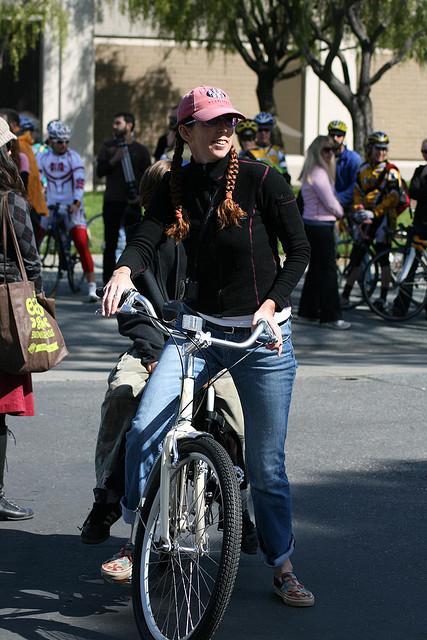Is the woman about to ride the bike?
Be succinct. Yes. What kind of vehicle is this?
Write a very short answer. Bicycle. Does her bike have a light on the front?
Answer briefly. No. What kind of shoes is the biker wearing?
Concise answer only. Tennis. What color is the hat?
Be succinct. Pink. What are the people on?
Give a very brief answer. Bikes. What is the girl doing?
Give a very brief answer. Riding. Is she wearing a helmet?
Write a very short answer. No. 